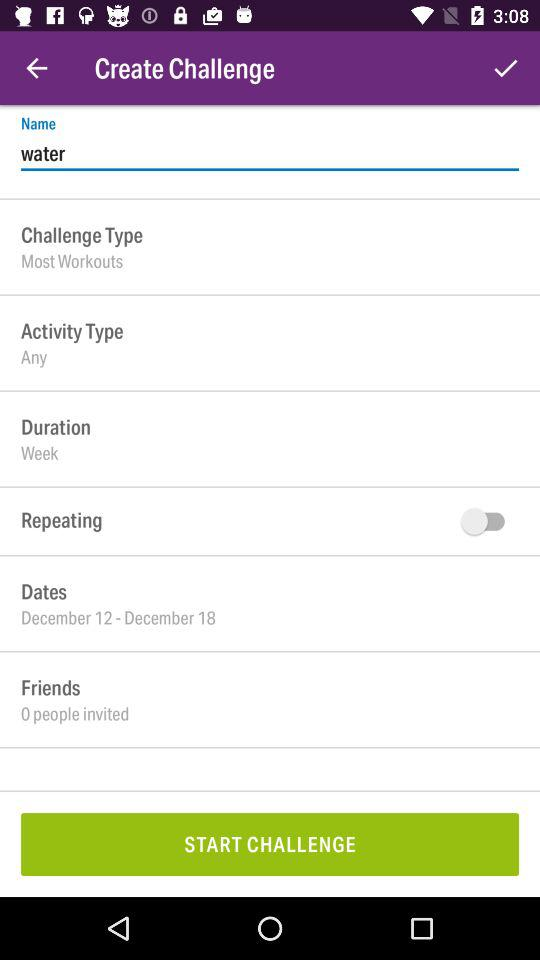How many friends have you sent invites to? You have sent invites to 0 friends. 